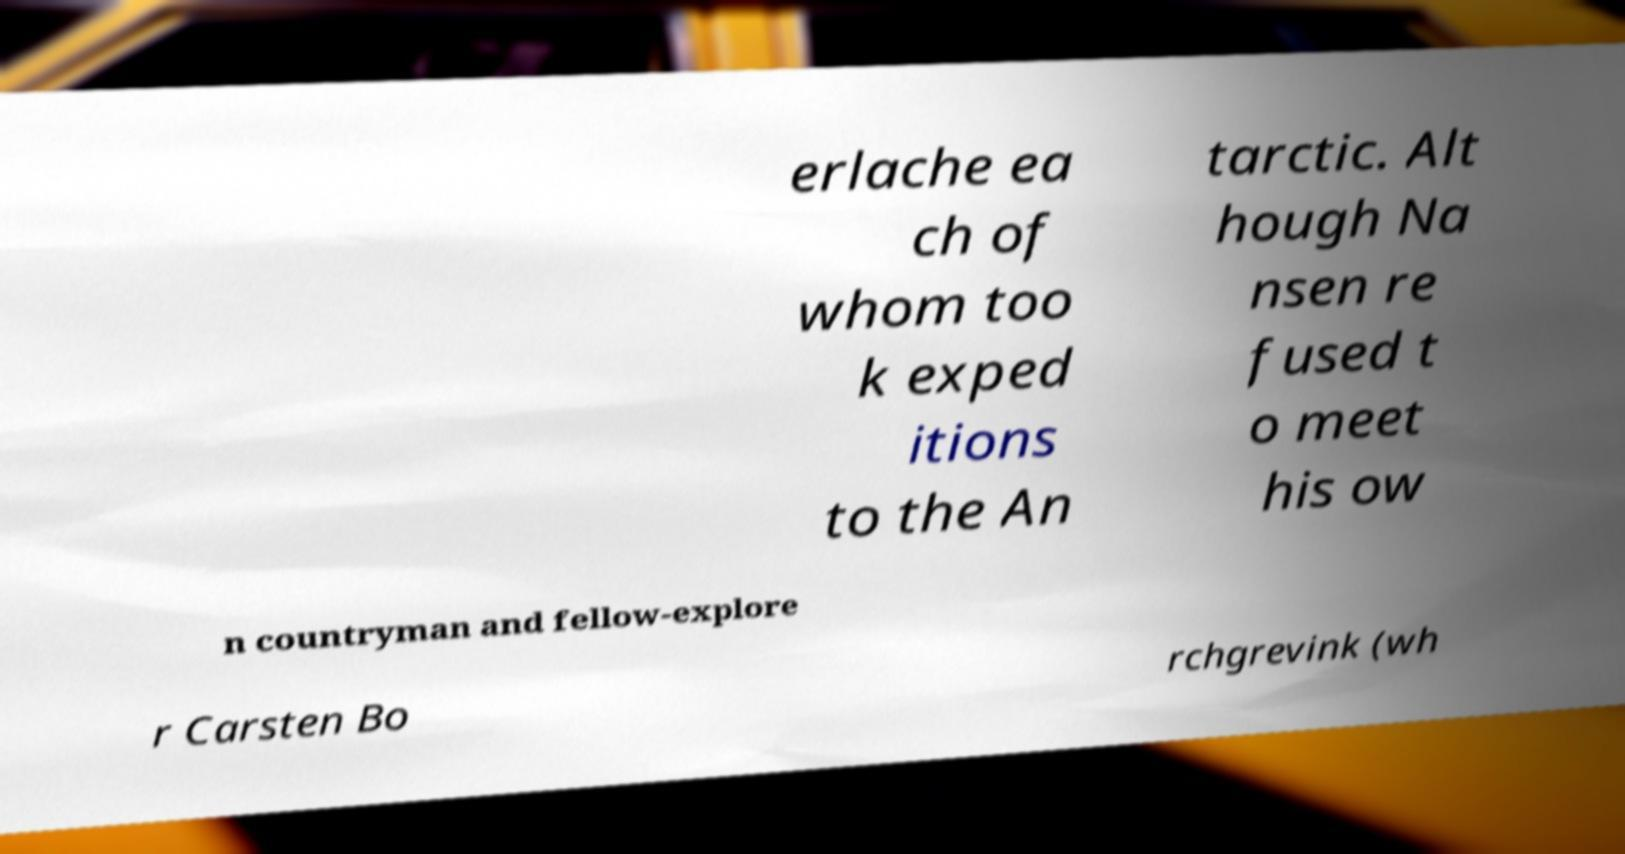Can you accurately transcribe the text from the provided image for me? erlache ea ch of whom too k exped itions to the An tarctic. Alt hough Na nsen re fused t o meet his ow n countryman and fellow-explore r Carsten Bo rchgrevink (wh 